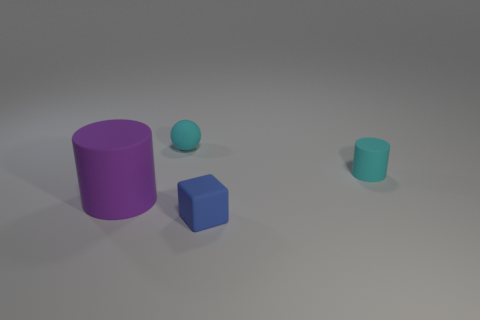Do the small rubber cylinder and the ball have the same color?
Your answer should be compact. Yes. Is the purple thing made of the same material as the tiny blue block?
Provide a succinct answer. Yes. Is there a big thing made of the same material as the cyan ball?
Provide a succinct answer. Yes. What is the color of the rubber cylinder to the right of the rubber cylinder that is on the left side of the tiny blue matte object on the right side of the purple matte cylinder?
Ensure brevity in your answer.  Cyan. What number of red things are either matte spheres or small rubber blocks?
Keep it short and to the point. 0. What number of small green rubber objects are the same shape as the large rubber thing?
Offer a very short reply. 0. There is a blue rubber thing that is the same size as the sphere; what shape is it?
Keep it short and to the point. Cube. There is a small blue object; are there any matte spheres in front of it?
Make the answer very short. No. There is a cyan rubber object that is right of the matte block; are there any small cyan spheres that are in front of it?
Your answer should be compact. No. Are there fewer cyan balls in front of the big purple matte thing than cyan rubber balls right of the sphere?
Offer a very short reply. No. 